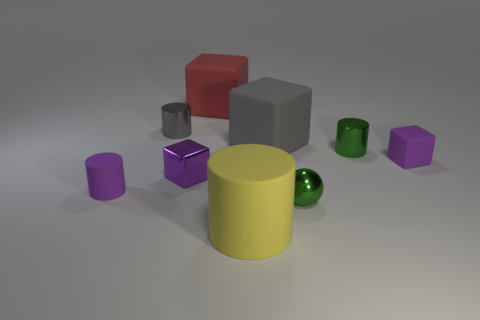Are there more large gray blocks to the right of the gray metal thing than large gray matte things right of the small green shiny sphere?
Give a very brief answer. Yes. How many other things are there of the same material as the green cylinder?
Ensure brevity in your answer.  3. Does the gray object on the right side of the large yellow cylinder have the same material as the green cylinder?
Give a very brief answer. No. The tiny gray metal thing is what shape?
Give a very brief answer. Cylinder. Is the number of small shiny cylinders that are on the left side of the small green shiny ball greater than the number of small cyan things?
Make the answer very short. Yes. There is a small rubber thing that is the same shape as the big red object; what color is it?
Offer a terse response. Purple. What is the shape of the purple thing that is right of the green metallic sphere?
Provide a succinct answer. Cube. There is a big yellow matte object; are there any big gray matte blocks behind it?
Keep it short and to the point. Yes. What is the color of the cube that is made of the same material as the tiny gray thing?
Keep it short and to the point. Purple. There is a small shiny cylinder on the left side of the large gray object; is its color the same as the large matte block in front of the red matte cube?
Provide a succinct answer. Yes. 